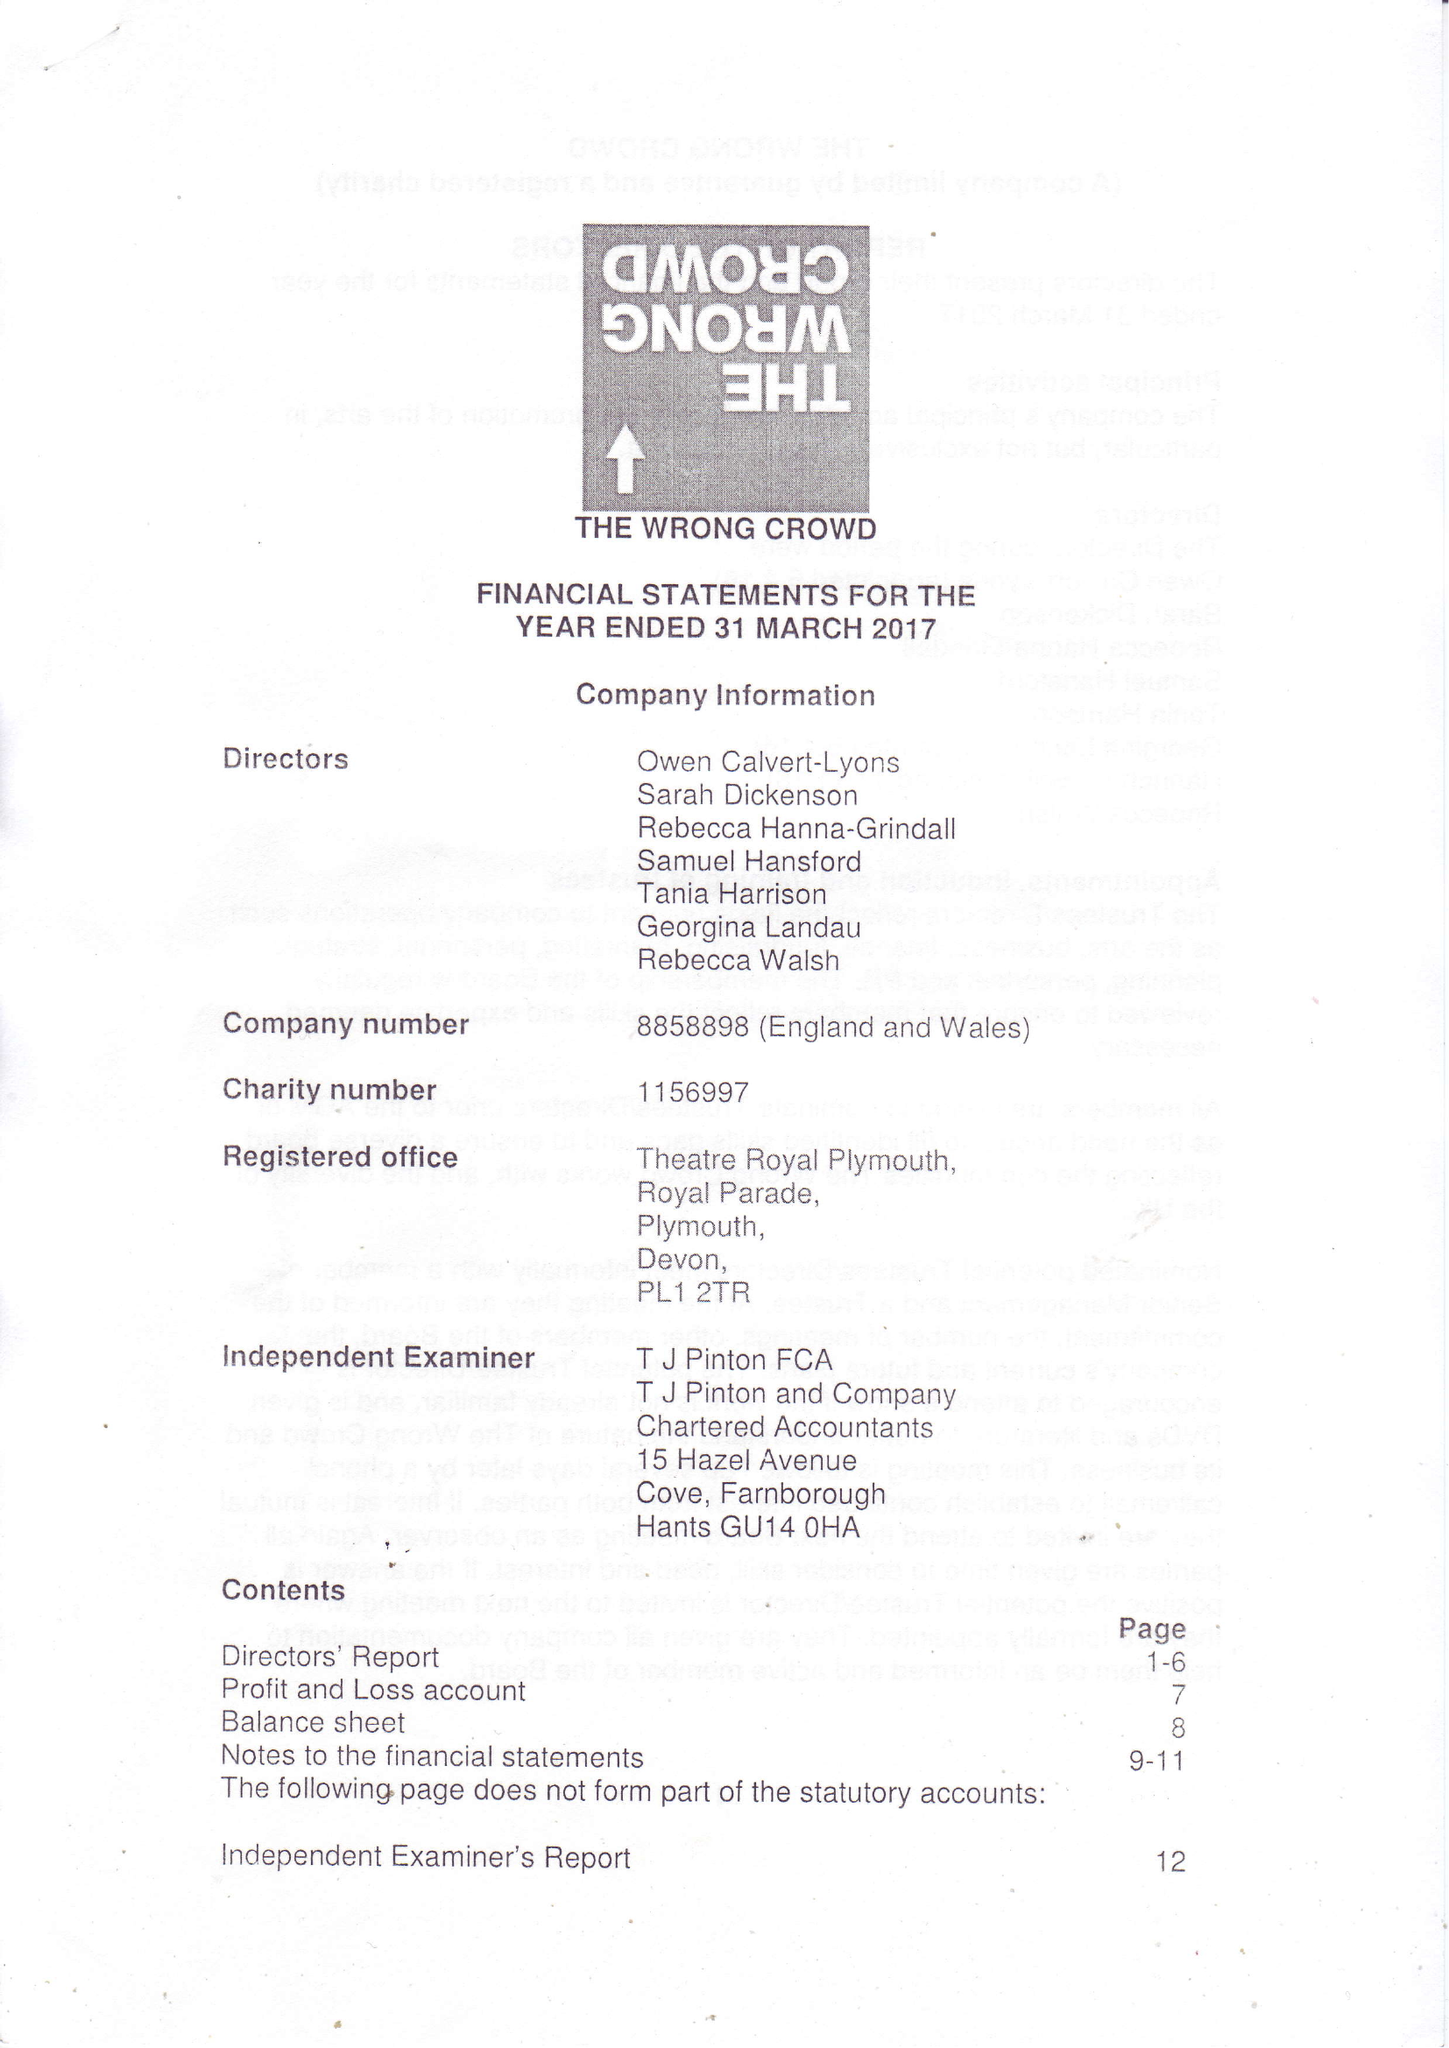What is the value for the address__postcode?
Answer the question using a single word or phrase. TQ9 6JG 